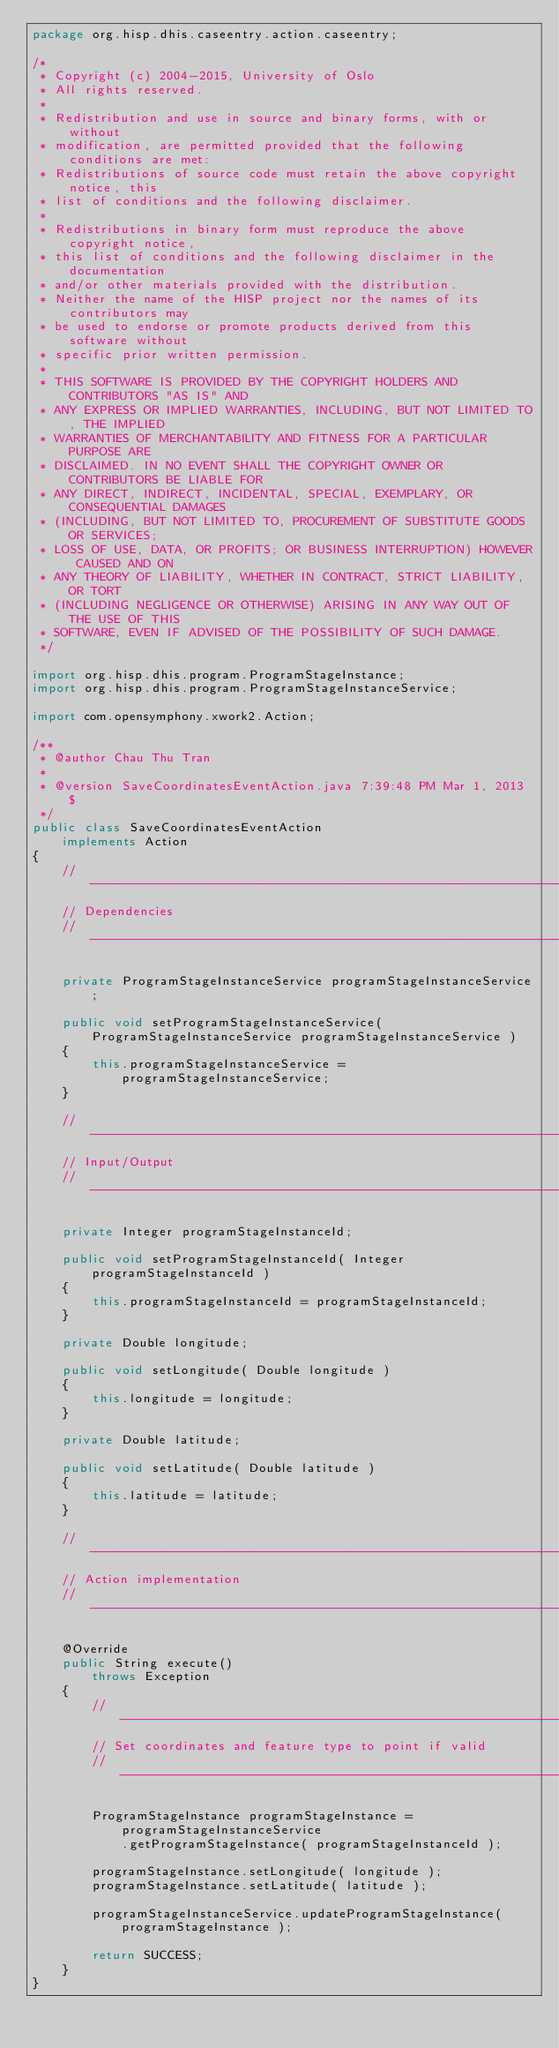<code> <loc_0><loc_0><loc_500><loc_500><_Java_>package org.hisp.dhis.caseentry.action.caseentry;

/*
 * Copyright (c) 2004-2015, University of Oslo
 * All rights reserved.
 *
 * Redistribution and use in source and binary forms, with or without
 * modification, are permitted provided that the following conditions are met:
 * Redistributions of source code must retain the above copyright notice, this
 * list of conditions and the following disclaimer.
 *
 * Redistributions in binary form must reproduce the above copyright notice,
 * this list of conditions and the following disclaimer in the documentation
 * and/or other materials provided with the distribution.
 * Neither the name of the HISP project nor the names of its contributors may
 * be used to endorse or promote products derived from this software without
 * specific prior written permission.
 *
 * THIS SOFTWARE IS PROVIDED BY THE COPYRIGHT HOLDERS AND CONTRIBUTORS "AS IS" AND
 * ANY EXPRESS OR IMPLIED WARRANTIES, INCLUDING, BUT NOT LIMITED TO, THE IMPLIED
 * WARRANTIES OF MERCHANTABILITY AND FITNESS FOR A PARTICULAR PURPOSE ARE
 * DISCLAIMED. IN NO EVENT SHALL THE COPYRIGHT OWNER OR CONTRIBUTORS BE LIABLE FOR
 * ANY DIRECT, INDIRECT, INCIDENTAL, SPECIAL, EXEMPLARY, OR CONSEQUENTIAL DAMAGES
 * (INCLUDING, BUT NOT LIMITED TO, PROCUREMENT OF SUBSTITUTE GOODS OR SERVICES;
 * LOSS OF USE, DATA, OR PROFITS; OR BUSINESS INTERRUPTION) HOWEVER CAUSED AND ON
 * ANY THEORY OF LIABILITY, WHETHER IN CONTRACT, STRICT LIABILITY, OR TORT
 * (INCLUDING NEGLIGENCE OR OTHERWISE) ARISING IN ANY WAY OUT OF THE USE OF THIS
 * SOFTWARE, EVEN IF ADVISED OF THE POSSIBILITY OF SUCH DAMAGE.
 */

import org.hisp.dhis.program.ProgramStageInstance;
import org.hisp.dhis.program.ProgramStageInstanceService;

import com.opensymphony.xwork2.Action;

/**
 * @author Chau Thu Tran
 * 
 * @version SaveCoordinatesEventAction.java 7:39:48 PM Mar 1, 2013 $
 */
public class SaveCoordinatesEventAction
    implements Action
{
    // -------------------------------------------------------------------------
    // Dependencies
    // -------------------------------------------------------------------------

    private ProgramStageInstanceService programStageInstanceService;

    public void setProgramStageInstanceService( ProgramStageInstanceService programStageInstanceService )
    {
        this.programStageInstanceService = programStageInstanceService;
    }

    // --------------------------------------------------------------------------
    // Input/Output
    // --------------------------------------------------------------------------

    private Integer programStageInstanceId;

    public void setProgramStageInstanceId( Integer programStageInstanceId )
    {
        this.programStageInstanceId = programStageInstanceId;
    }

    private Double longitude;

    public void setLongitude( Double longitude )
    {
        this.longitude = longitude;
    }

    private Double latitude;

    public void setLatitude( Double latitude )
    {
        this.latitude = latitude;
    }

    // --------------------------------------------------------------------------
    // Action implementation
    // --------------------------------------------------------------------------

    @Override
    public String execute()
        throws Exception
    {
        // ---------------------------------------------------------------------
        // Set coordinates and feature type to point if valid
        // ---------------------------------------------------------------------

        ProgramStageInstance programStageInstance = programStageInstanceService
            .getProgramStageInstance( programStageInstanceId );

        programStageInstance.setLongitude( longitude );
        programStageInstance.setLatitude( latitude );
            
        programStageInstanceService.updateProgramStageInstance( programStageInstance );

        return SUCCESS;
    }
}
</code> 